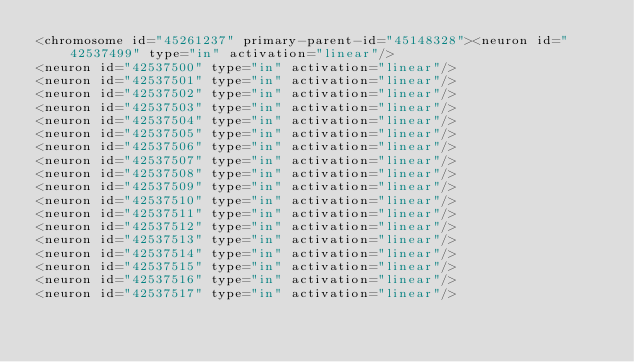<code> <loc_0><loc_0><loc_500><loc_500><_XML_><chromosome id="45261237" primary-parent-id="45148328"><neuron id="42537499" type="in" activation="linear"/>
<neuron id="42537500" type="in" activation="linear"/>
<neuron id="42537501" type="in" activation="linear"/>
<neuron id="42537502" type="in" activation="linear"/>
<neuron id="42537503" type="in" activation="linear"/>
<neuron id="42537504" type="in" activation="linear"/>
<neuron id="42537505" type="in" activation="linear"/>
<neuron id="42537506" type="in" activation="linear"/>
<neuron id="42537507" type="in" activation="linear"/>
<neuron id="42537508" type="in" activation="linear"/>
<neuron id="42537509" type="in" activation="linear"/>
<neuron id="42537510" type="in" activation="linear"/>
<neuron id="42537511" type="in" activation="linear"/>
<neuron id="42537512" type="in" activation="linear"/>
<neuron id="42537513" type="in" activation="linear"/>
<neuron id="42537514" type="in" activation="linear"/>
<neuron id="42537515" type="in" activation="linear"/>
<neuron id="42537516" type="in" activation="linear"/>
<neuron id="42537517" type="in" activation="linear"/></code> 